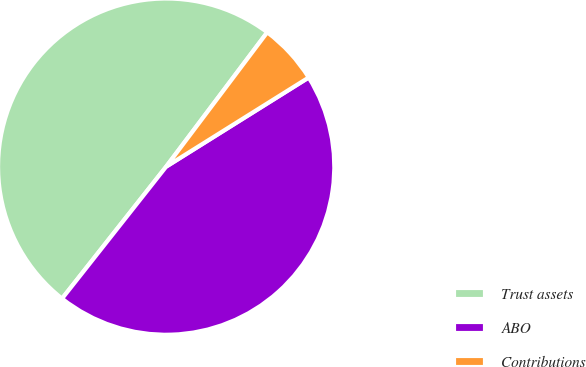Convert chart. <chart><loc_0><loc_0><loc_500><loc_500><pie_chart><fcel>Trust assets<fcel>ABO<fcel>Contributions<nl><fcel>49.64%<fcel>44.53%<fcel>5.84%<nl></chart> 